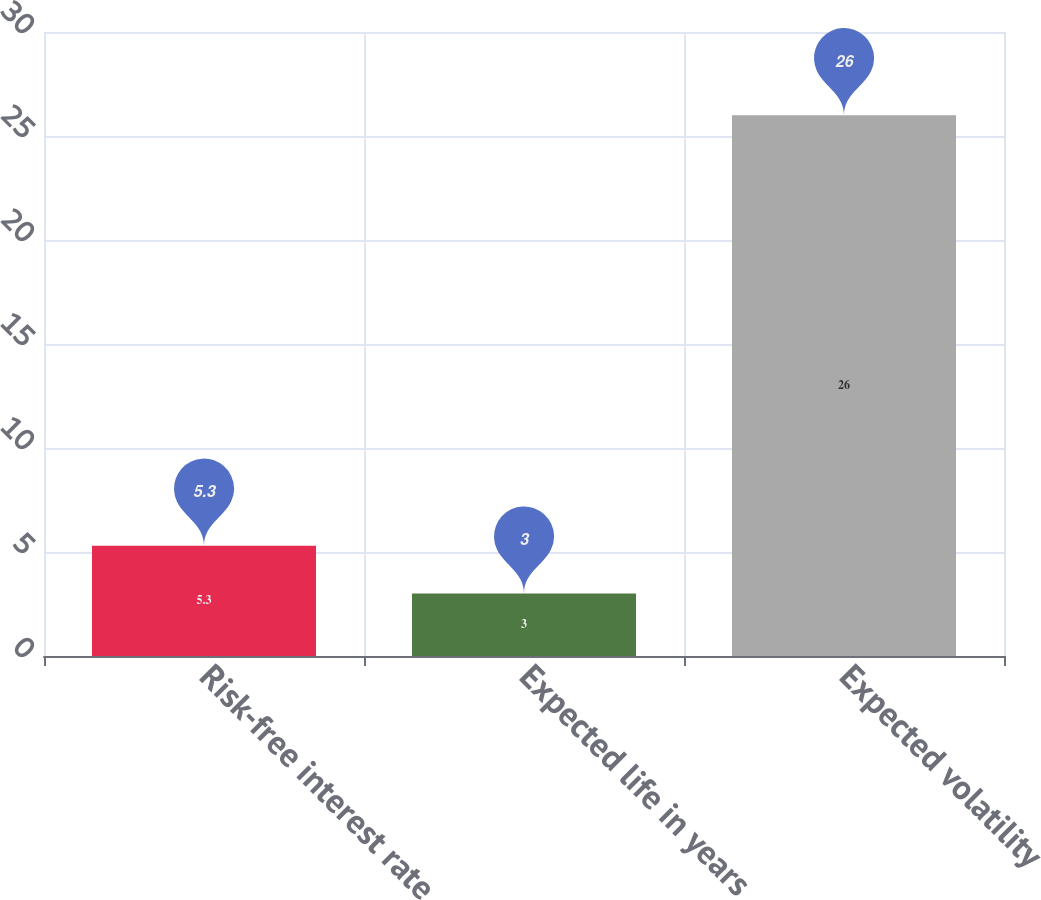Convert chart to OTSL. <chart><loc_0><loc_0><loc_500><loc_500><bar_chart><fcel>Risk-free interest rate<fcel>Expected life in years<fcel>Expected volatility<nl><fcel>5.3<fcel>3<fcel>26<nl></chart> 